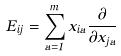<formula> <loc_0><loc_0><loc_500><loc_500>E _ { i j } = \sum _ { a = 1 } ^ { m } x _ { i a } \frac { \partial } { \partial x _ { j a } }</formula> 